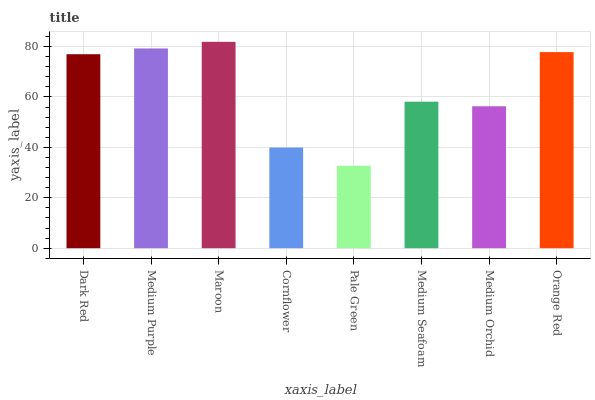Is Pale Green the minimum?
Answer yes or no. Yes. Is Maroon the maximum?
Answer yes or no. Yes. Is Medium Purple the minimum?
Answer yes or no. No. Is Medium Purple the maximum?
Answer yes or no. No. Is Medium Purple greater than Dark Red?
Answer yes or no. Yes. Is Dark Red less than Medium Purple?
Answer yes or no. Yes. Is Dark Red greater than Medium Purple?
Answer yes or no. No. Is Medium Purple less than Dark Red?
Answer yes or no. No. Is Dark Red the high median?
Answer yes or no. Yes. Is Medium Seafoam the low median?
Answer yes or no. Yes. Is Pale Green the high median?
Answer yes or no. No. Is Orange Red the low median?
Answer yes or no. No. 